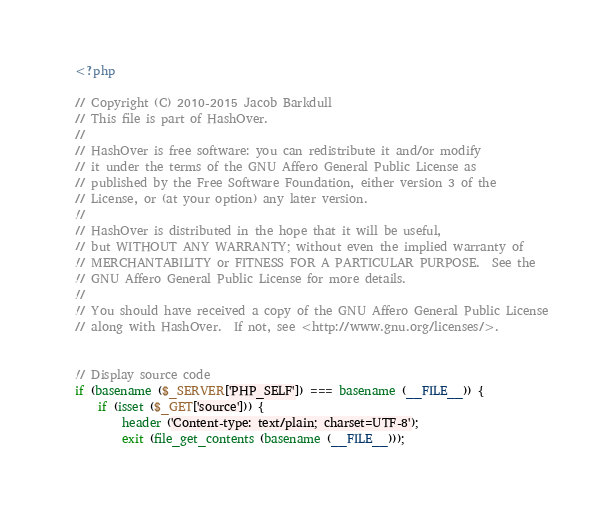Convert code to text. <code><loc_0><loc_0><loc_500><loc_500><_PHP_><?php

// Copyright (C) 2010-2015 Jacob Barkdull
// This file is part of HashOver.
//
// HashOver is free software: you can redistribute it and/or modify
// it under the terms of the GNU Affero General Public License as
// published by the Free Software Foundation, either version 3 of the
// License, or (at your option) any later version.
//
// HashOver is distributed in the hope that it will be useful,
// but WITHOUT ANY WARRANTY; without even the implied warranty of
// MERCHANTABILITY or FITNESS FOR A PARTICULAR PURPOSE.  See the
// GNU Affero General Public License for more details.
//
// You should have received a copy of the GNU Affero General Public License
// along with HashOver.  If not, see <http://www.gnu.org/licenses/>.


// Display source code
if (basename ($_SERVER['PHP_SELF']) === basename (__FILE__)) {
	if (isset ($_GET['source'])) {
		header ('Content-type: text/plain; charset=UTF-8');
		exit (file_get_contents (basename (__FILE__)));</code> 